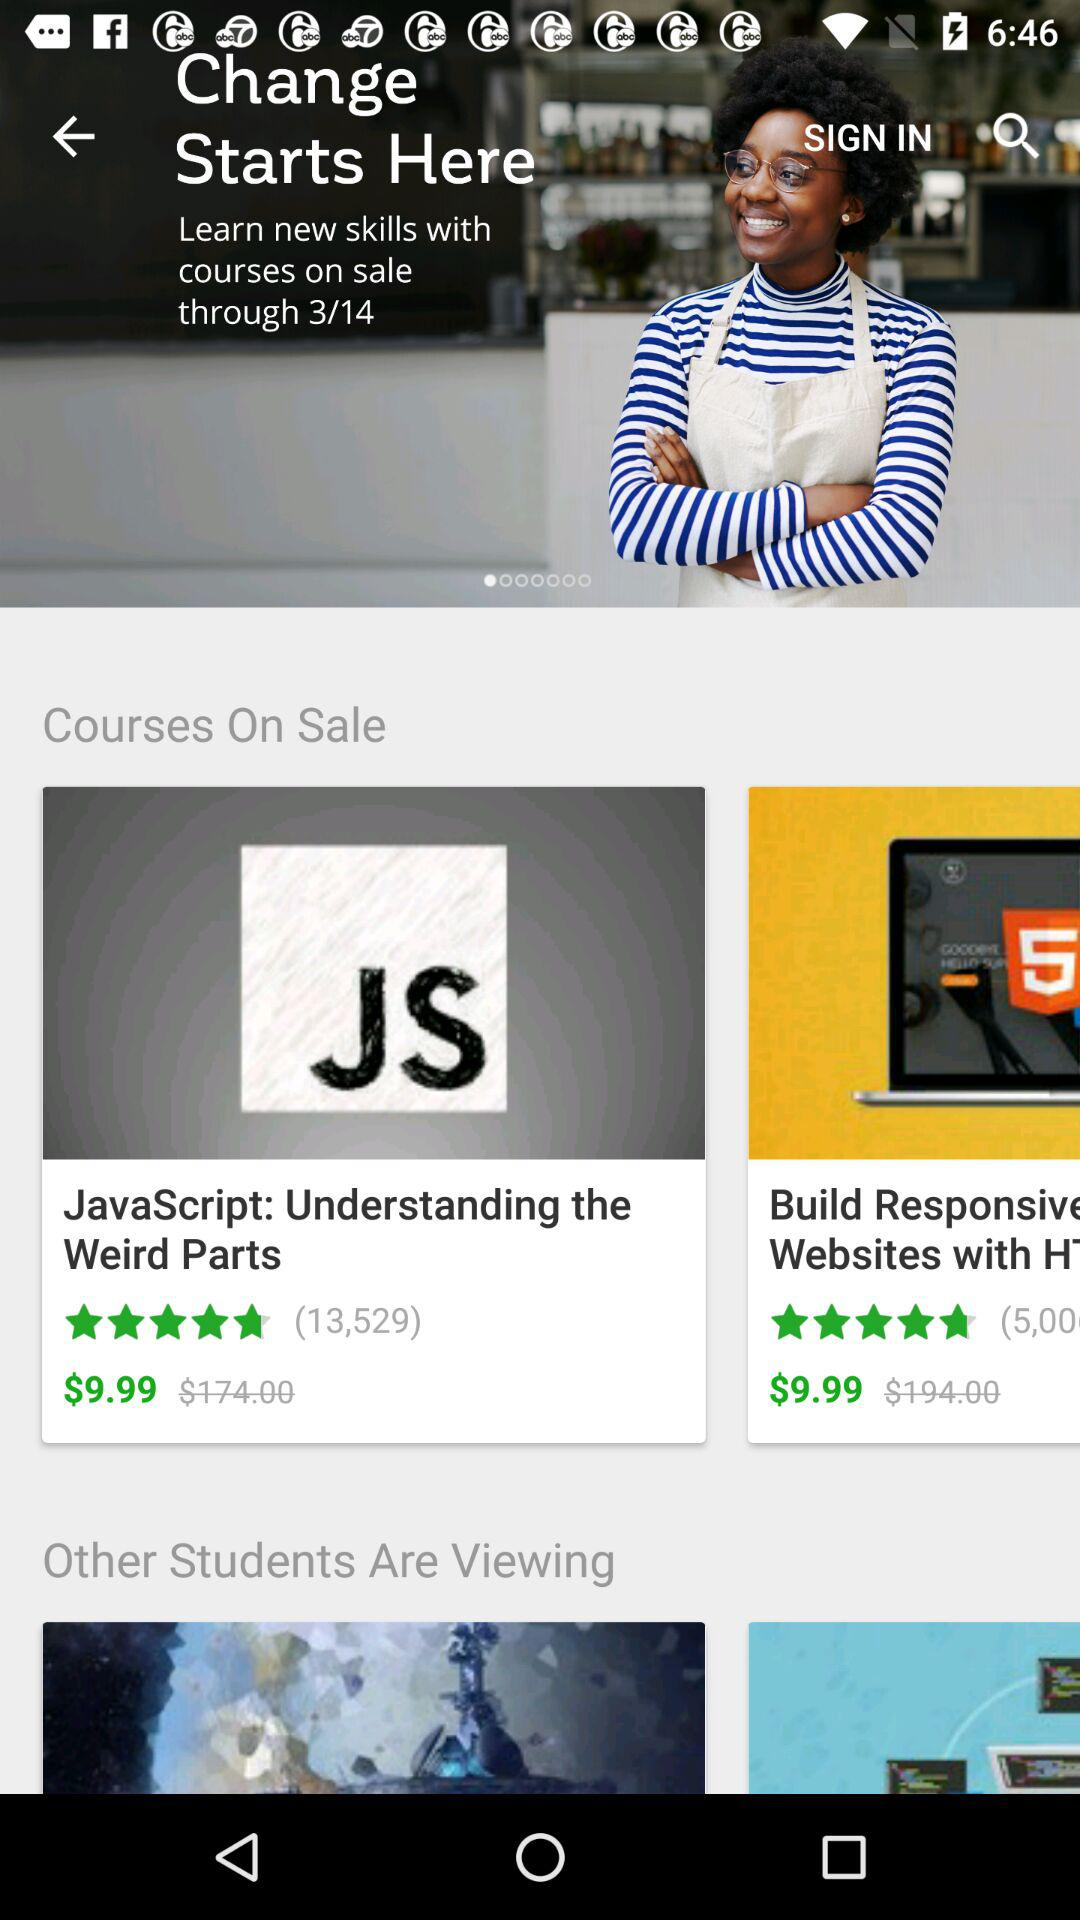What is the Build responsive course fee?
When the provided information is insufficient, respond with <no answer>. <no answer> 